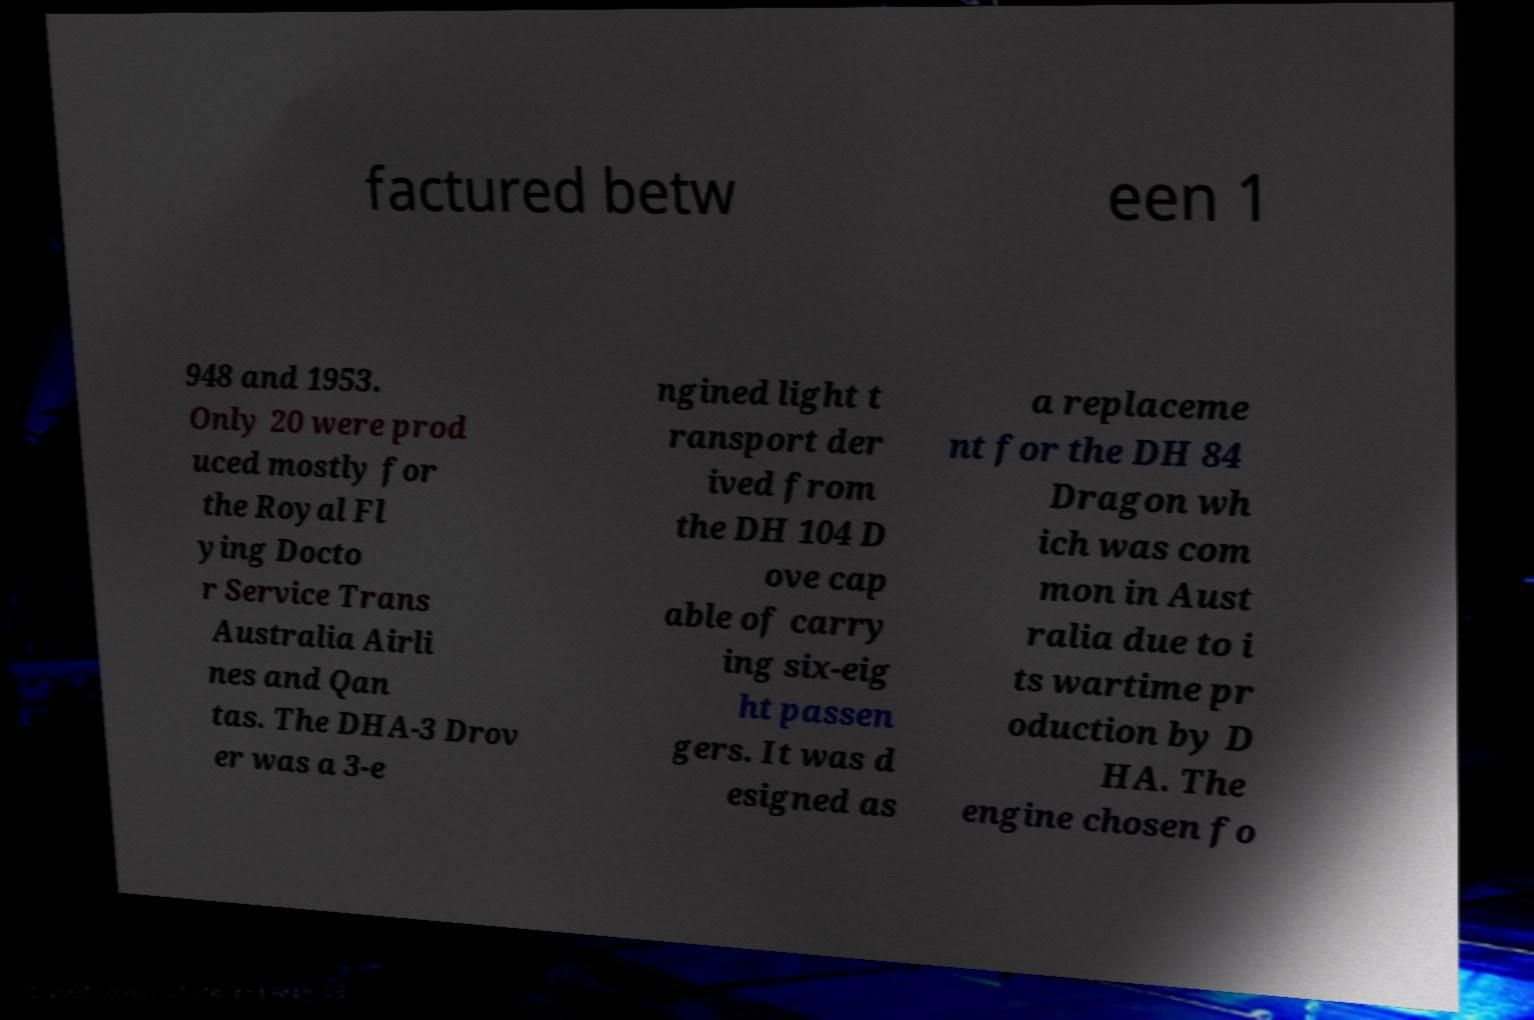What messages or text are displayed in this image? I need them in a readable, typed format. factured betw een 1 948 and 1953. Only 20 were prod uced mostly for the Royal Fl ying Docto r Service Trans Australia Airli nes and Qan tas. The DHA-3 Drov er was a 3-e ngined light t ransport der ived from the DH 104 D ove cap able of carry ing six-eig ht passen gers. It was d esigned as a replaceme nt for the DH 84 Dragon wh ich was com mon in Aust ralia due to i ts wartime pr oduction by D HA. The engine chosen fo 